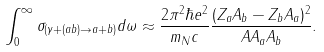Convert formula to latex. <formula><loc_0><loc_0><loc_500><loc_500>\int _ { 0 } ^ { \infty } \sigma _ { ( \gamma + ( a b ) \rightarrow a + b ) } d \omega \approx \frac { 2 \pi ^ { 2 } \hbar { e } ^ { 2 } } { m _ { N } c } \frac { ( Z _ { a } A _ { b } - Z _ { b } A _ { a } ) ^ { 2 } } { A A _ { a } A _ { b } } .</formula> 